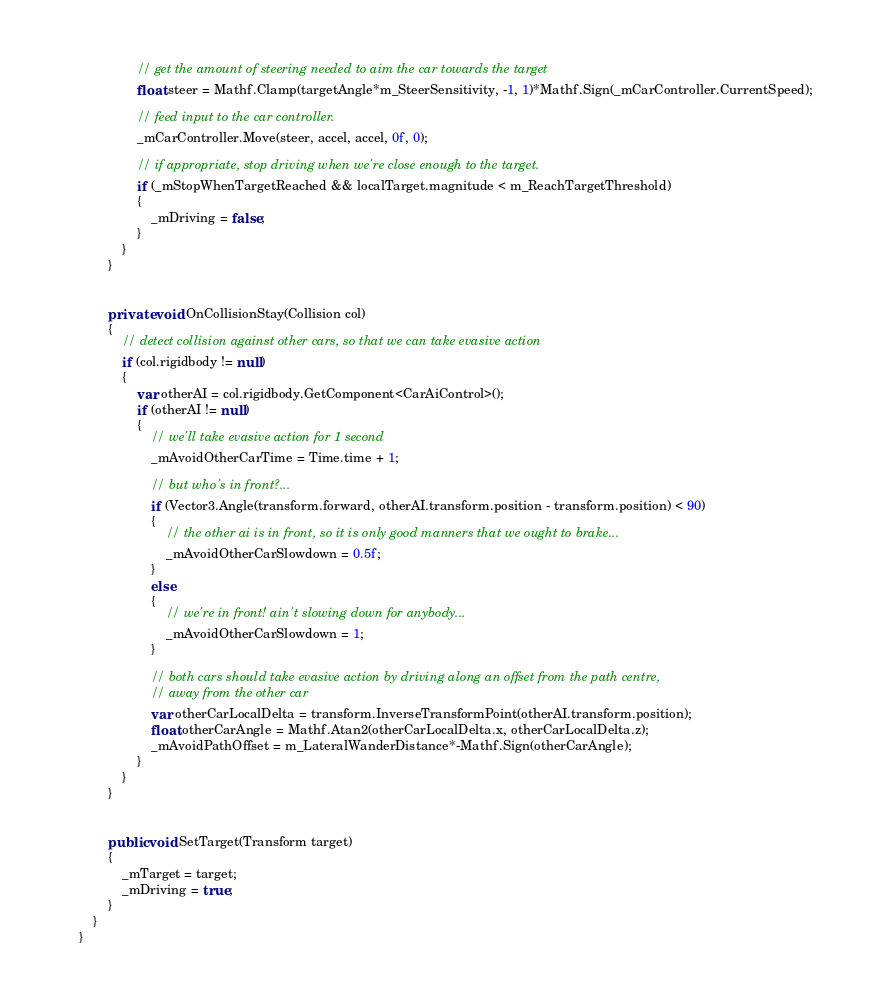<code> <loc_0><loc_0><loc_500><loc_500><_C#_>
                // get the amount of steering needed to aim the car towards the target
                float steer = Mathf.Clamp(targetAngle*m_SteerSensitivity, -1, 1)*Mathf.Sign(_mCarController.CurrentSpeed);

                // feed input to the car controller.
                _mCarController.Move(steer, accel, accel, 0f, 0);

                // if appropriate, stop driving when we're close enough to the target.
                if (_mStopWhenTargetReached && localTarget.magnitude < m_ReachTargetThreshold)
                {
                    _mDriving = false;
                }
            }
        }


        private void OnCollisionStay(Collision col)
        {
            // detect collision against other cars, so that we can take evasive action
            if (col.rigidbody != null)
            {
                var otherAI = col.rigidbody.GetComponent<CarAiControl>();
                if (otherAI != null)
                {
                    // we'll take evasive action for 1 second
                    _mAvoidOtherCarTime = Time.time + 1;

                    // but who's in front?...
                    if (Vector3.Angle(transform.forward, otherAI.transform.position - transform.position) < 90)
                    {
                        // the other ai is in front, so it is only good manners that we ought to brake...
                        _mAvoidOtherCarSlowdown = 0.5f;
                    }
                    else
                    {
                        // we're in front! ain't slowing down for anybody...
                        _mAvoidOtherCarSlowdown = 1;
                    }

                    // both cars should take evasive action by driving along an offset from the path centre,
                    // away from the other car
                    var otherCarLocalDelta = transform.InverseTransformPoint(otherAI.transform.position);
                    float otherCarAngle = Mathf.Atan2(otherCarLocalDelta.x, otherCarLocalDelta.z);
                    _mAvoidPathOffset = m_LateralWanderDistance*-Mathf.Sign(otherCarAngle);
                }
            }
        }


        public void SetTarget(Transform target)
        {
            _mTarget = target;
            _mDriving = true;
        }
    }
}
</code> 